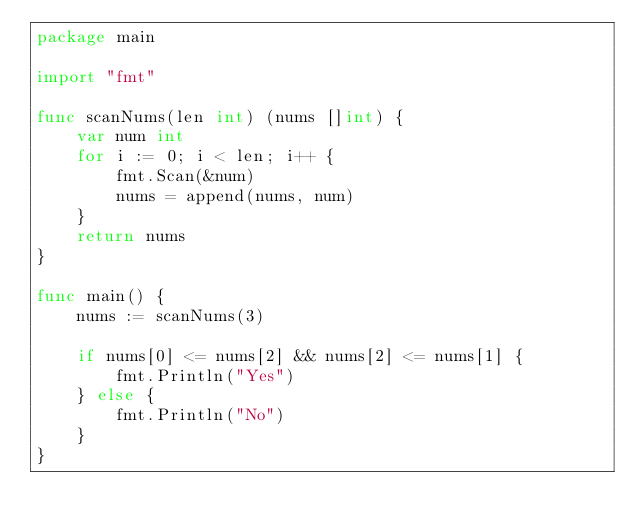<code> <loc_0><loc_0><loc_500><loc_500><_Go_>package main

import "fmt"

func scanNums(len int) (nums []int) {
	var num int
	for i := 0; i < len; i++ {
		fmt.Scan(&num)
		nums = append(nums, num)
	}
	return nums
}

func main() {
	nums := scanNums(3)

	if nums[0] <= nums[2] && nums[2] <= nums[1] {
		fmt.Println("Yes")
	} else {
		fmt.Println("No")
	}
}
</code> 